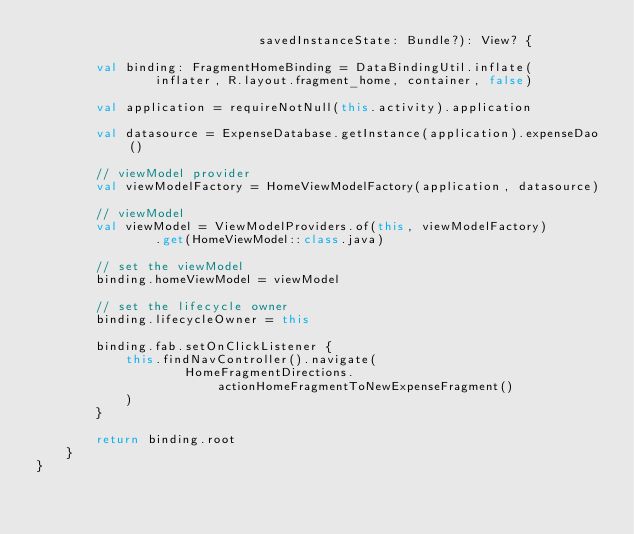<code> <loc_0><loc_0><loc_500><loc_500><_Kotlin_>                              savedInstanceState: Bundle?): View? {

        val binding: FragmentHomeBinding = DataBindingUtil.inflate(
                inflater, R.layout.fragment_home, container, false)

        val application = requireNotNull(this.activity).application

        val datasource = ExpenseDatabase.getInstance(application).expenseDao()

        // viewModel provider
        val viewModelFactory = HomeViewModelFactory(application, datasource)

        // viewModel
        val viewModel = ViewModelProviders.of(this, viewModelFactory)
                .get(HomeViewModel::class.java)

        // set the viewModel
        binding.homeViewModel = viewModel

        // set the lifecycle owner
        binding.lifecycleOwner = this

        binding.fab.setOnClickListener {
            this.findNavController().navigate(
                    HomeFragmentDirections.actionHomeFragmentToNewExpenseFragment()
            )
        }

        return binding.root
    }
}</code> 